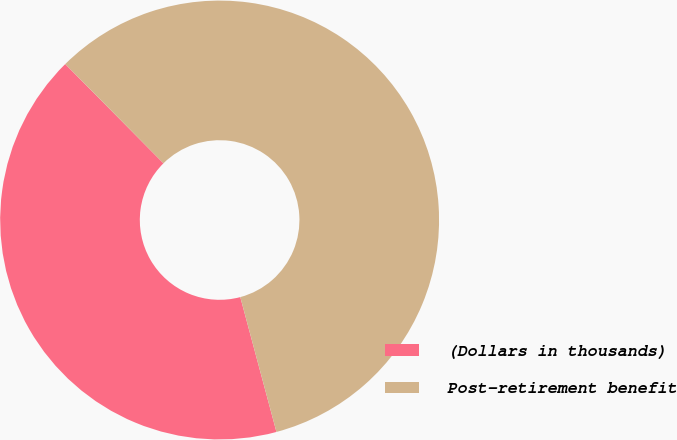<chart> <loc_0><loc_0><loc_500><loc_500><pie_chart><fcel>(Dollars in thousands)<fcel>Post-retirement benefit<nl><fcel>41.75%<fcel>58.25%<nl></chart> 